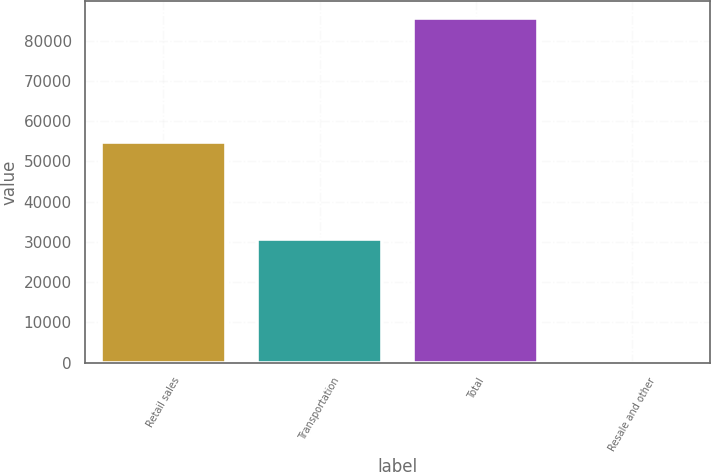Convert chart. <chart><loc_0><loc_0><loc_500><loc_500><bar_chart><fcel>Retail sales<fcel>Transportation<fcel>Total<fcel>Resale and other<nl><fcel>54782<fcel>30763<fcel>85545<fcel>40<nl></chart> 